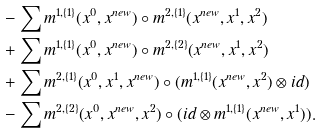Convert formula to latex. <formula><loc_0><loc_0><loc_500><loc_500>& - \sum m ^ { 1 , \{ 1 \} } ( x ^ { 0 } , x ^ { n e w } ) \circ m ^ { 2 , \{ 1 \} } ( x ^ { n e w } , x ^ { 1 } , x ^ { 2 } ) \\ & + \sum m ^ { 1 , \{ 1 \} } ( x ^ { 0 } , x ^ { n e w } ) \circ m ^ { 2 , \{ 2 \} } ( x ^ { n e w } , x ^ { 1 } , x ^ { 2 } ) \\ & + \sum m ^ { 2 , \{ 1 \} } ( x ^ { 0 } , x ^ { 1 } , x ^ { n e w } ) \circ ( m ^ { 1 , \{ 1 \} } ( x ^ { n e w } , x ^ { 2 } ) \otimes i d ) \\ & - \sum m ^ { 2 , \{ 2 \} } ( x ^ { 0 } , x ^ { n e w } , x ^ { 2 } ) \circ ( i d \otimes m ^ { 1 , \{ 1 \} } ( x ^ { n e w } , x ^ { 1 } ) ) .</formula> 